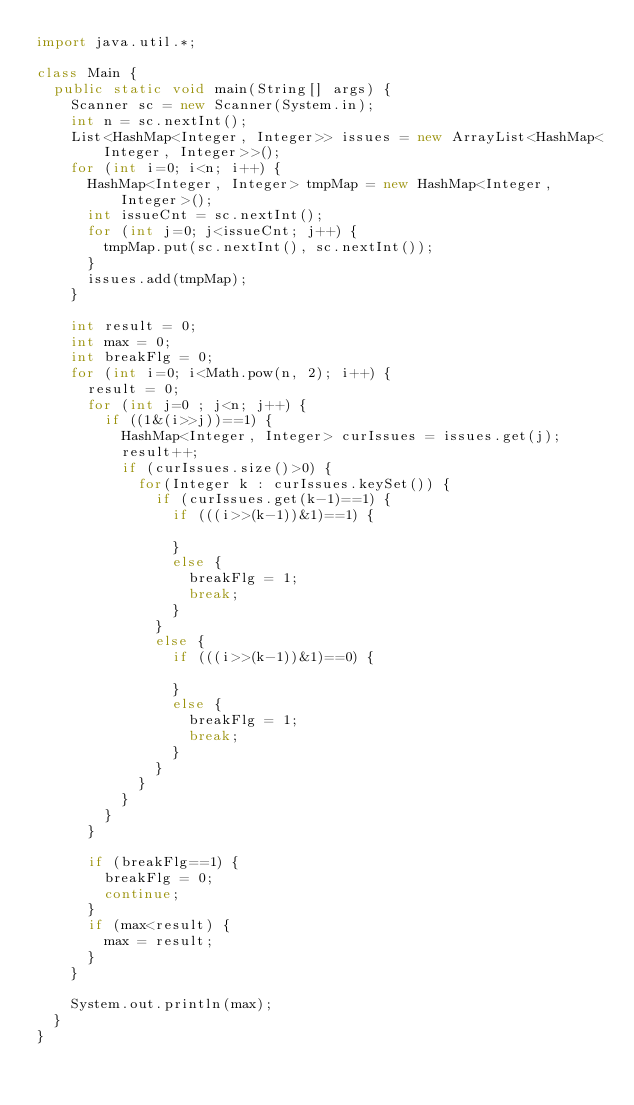<code> <loc_0><loc_0><loc_500><loc_500><_Java_>import java.util.*;

class Main {
  public static void main(String[] args) {
    Scanner sc = new Scanner(System.in);
    int n = sc.nextInt();
    List<HashMap<Integer, Integer>> issues = new ArrayList<HashMap<Integer, Integer>>();
    for (int i=0; i<n; i++) {
      HashMap<Integer, Integer> tmpMap = new HashMap<Integer, Integer>();
      int issueCnt = sc.nextInt();
      for (int j=0; j<issueCnt; j++) {
        tmpMap.put(sc.nextInt(), sc.nextInt());
      }
      issues.add(tmpMap);
    }
    
    int result = 0;
    int max = 0;
    int breakFlg = 0;
    for (int i=0; i<Math.pow(n, 2); i++) {
      result = 0;
      for (int j=0 ; j<n; j++) {
        if ((1&(i>>j))==1) {
          HashMap<Integer, Integer> curIssues = issues.get(j);
          result++;
          if (curIssues.size()>0) {
            for(Integer k : curIssues.keySet()) {
              if (curIssues.get(k-1)==1) {
                if (((i>>(k-1))&1)==1) {
                  
                }
                else {
                  breakFlg = 1;
                  break;
                }
              }
              else {
                if (((i>>(k-1))&1)==0) {
                  
                }
                else {
                  breakFlg = 1;
                  break;
                }
              }
            }
          }
        }
      }
      
      if (breakFlg==1) {
        breakFlg = 0;
        continue;
      }
      if (max<result) {
        max = result;
      }
    }
    
    System.out.println(max);
  }
}
</code> 